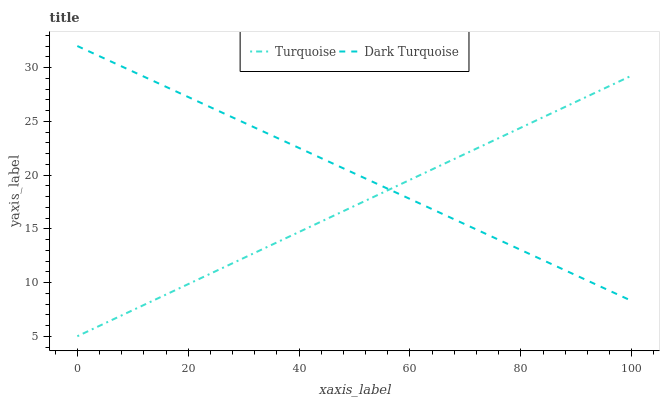Does Turquoise have the minimum area under the curve?
Answer yes or no. Yes. Does Dark Turquoise have the maximum area under the curve?
Answer yes or no. Yes. Does Turquoise have the maximum area under the curve?
Answer yes or no. No. Is Dark Turquoise the smoothest?
Answer yes or no. Yes. Is Turquoise the roughest?
Answer yes or no. Yes. Is Turquoise the smoothest?
Answer yes or no. No. Does Turquoise have the lowest value?
Answer yes or no. Yes. Does Dark Turquoise have the highest value?
Answer yes or no. Yes. Does Turquoise have the highest value?
Answer yes or no. No. Does Turquoise intersect Dark Turquoise?
Answer yes or no. Yes. Is Turquoise less than Dark Turquoise?
Answer yes or no. No. Is Turquoise greater than Dark Turquoise?
Answer yes or no. No. 